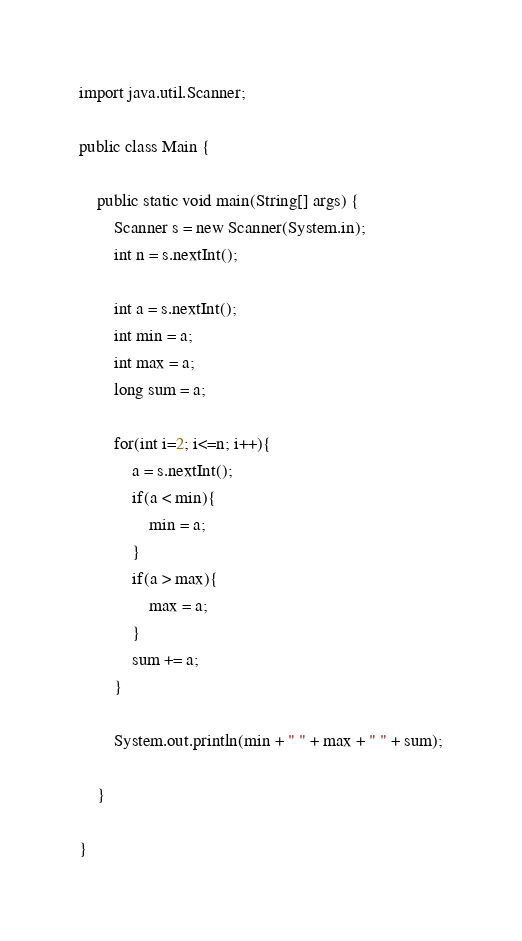<code> <loc_0><loc_0><loc_500><loc_500><_Java_>import java.util.Scanner;

public class Main {

	public static void main(String[] args) {
		Scanner s = new Scanner(System.in);
		int n = s.nextInt();
		
		int a = s.nextInt();
		int min = a;
		int max = a;
		long sum = a;
		
		for(int i=2; i<=n; i++){
			a = s.nextInt();
			if(a < min){
				min = a;
			}
			if(a > max){
				max = a;
			}
			sum += a;
		}
		
		System.out.println(min + " " + max + " " + sum);
		
	}

}</code> 